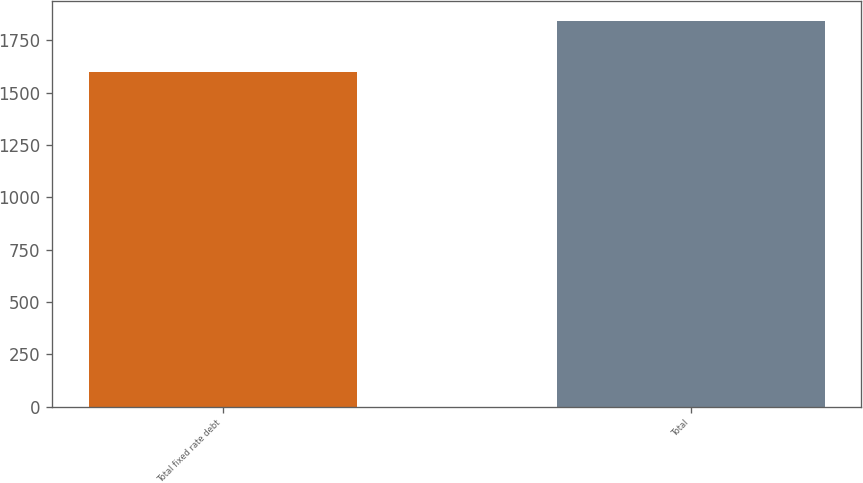<chart> <loc_0><loc_0><loc_500><loc_500><bar_chart><fcel>Total fixed rate debt<fcel>Total<nl><fcel>1599<fcel>1843<nl></chart> 